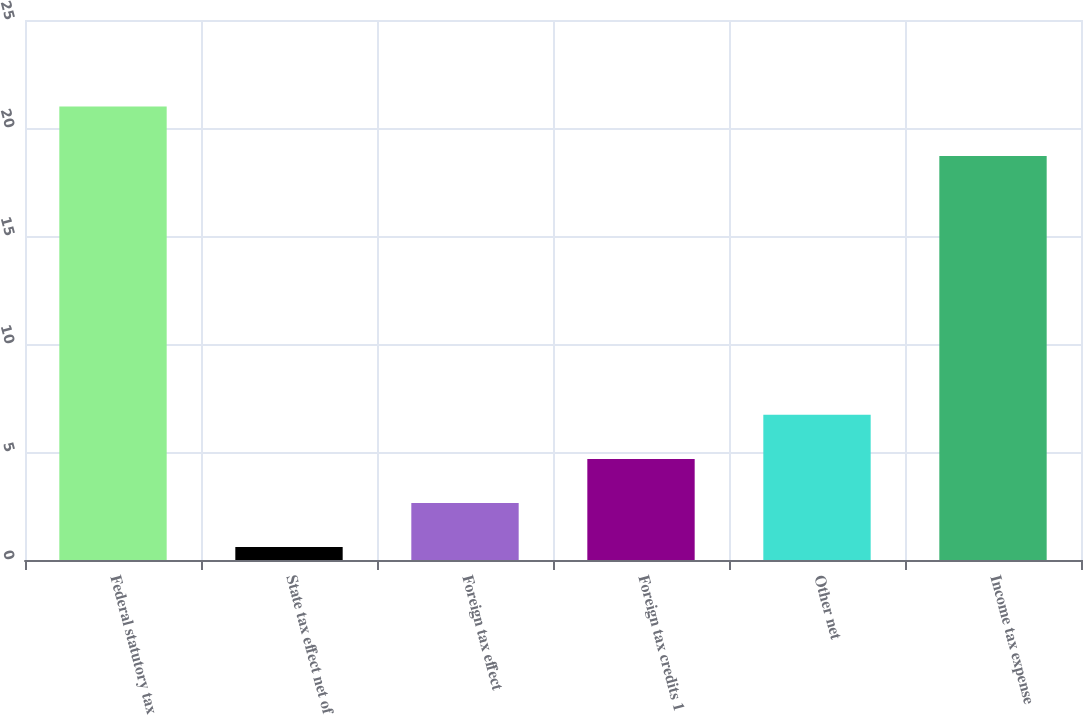Convert chart to OTSL. <chart><loc_0><loc_0><loc_500><loc_500><bar_chart><fcel>Federal statutory tax<fcel>State tax effect net of<fcel>Foreign tax effect<fcel>Foreign tax credits 1<fcel>Other net<fcel>Income tax expense<nl><fcel>21<fcel>0.6<fcel>2.64<fcel>4.68<fcel>6.72<fcel>18.7<nl></chart> 